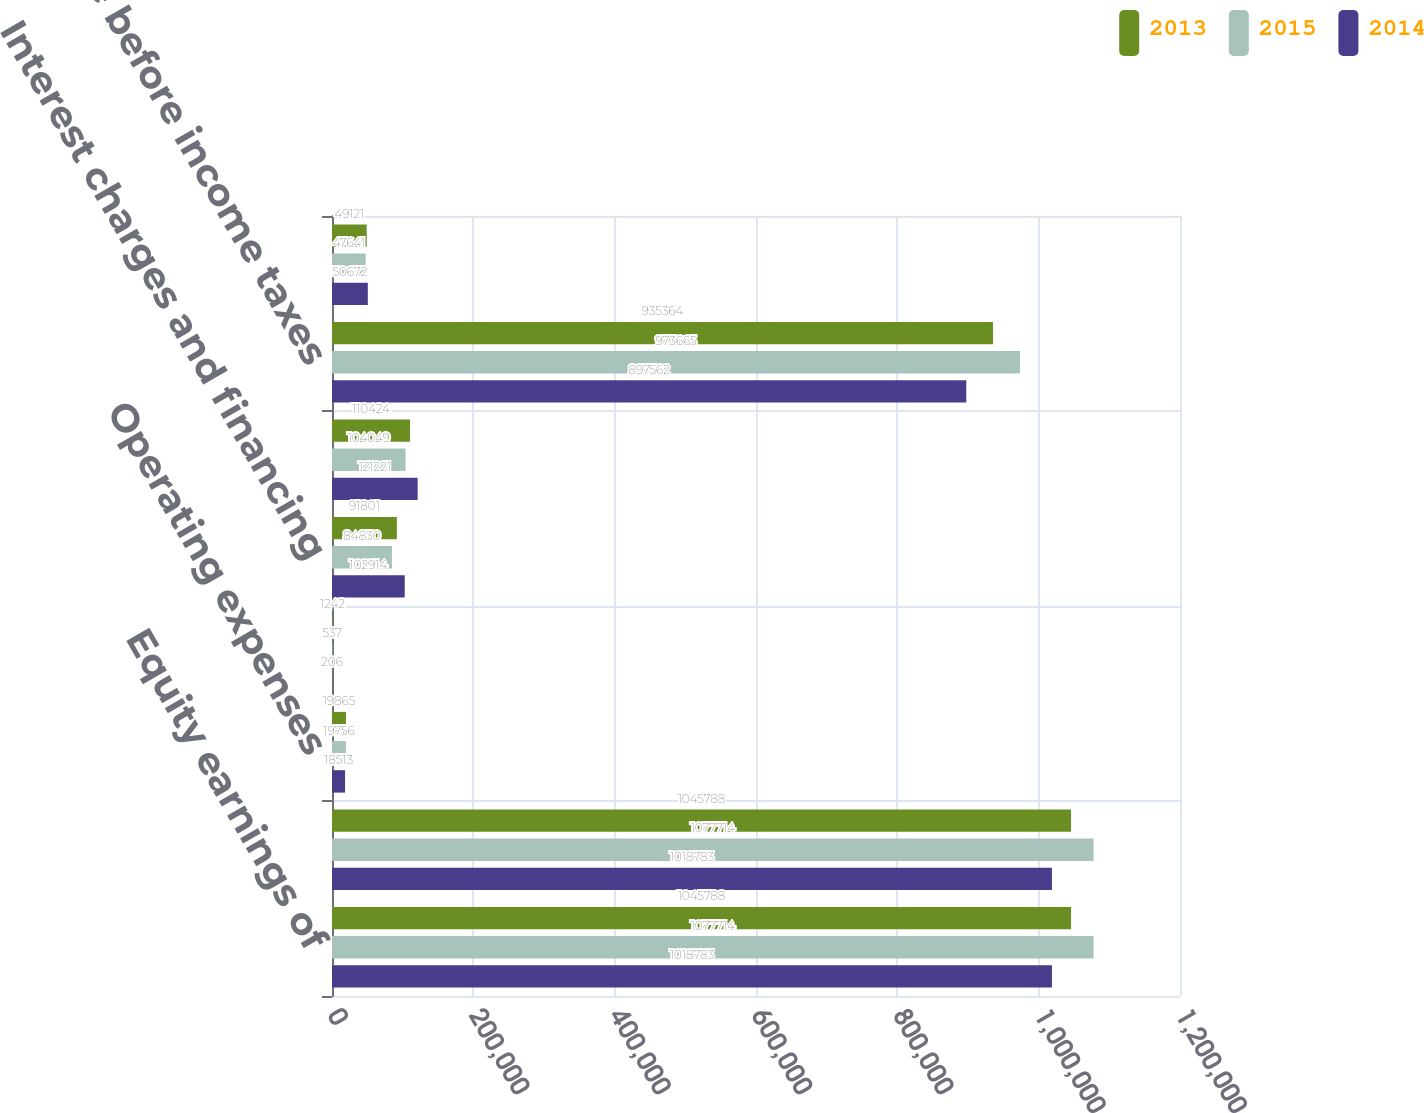Convert chart. <chart><loc_0><loc_0><loc_500><loc_500><stacked_bar_chart><ecel><fcel>Equity earnings of<fcel>Total income<fcel>Operating expenses<fcel>Other income<fcel>Interest charges and financing<fcel>Total expenses and other<fcel>Income before income taxes<fcel>Income tax benefit<nl><fcel>2013<fcel>1.04579e+06<fcel>1.04579e+06<fcel>19865<fcel>1242<fcel>91801<fcel>110424<fcel>935364<fcel>49121<nl><fcel>2015<fcel>1.07771e+06<fcel>1.07771e+06<fcel>19756<fcel>537<fcel>84830<fcel>104049<fcel>973665<fcel>47641<nl><fcel>2014<fcel>1.01878e+06<fcel>1.01878e+06<fcel>18513<fcel>206<fcel>102914<fcel>121221<fcel>897562<fcel>50672<nl></chart> 